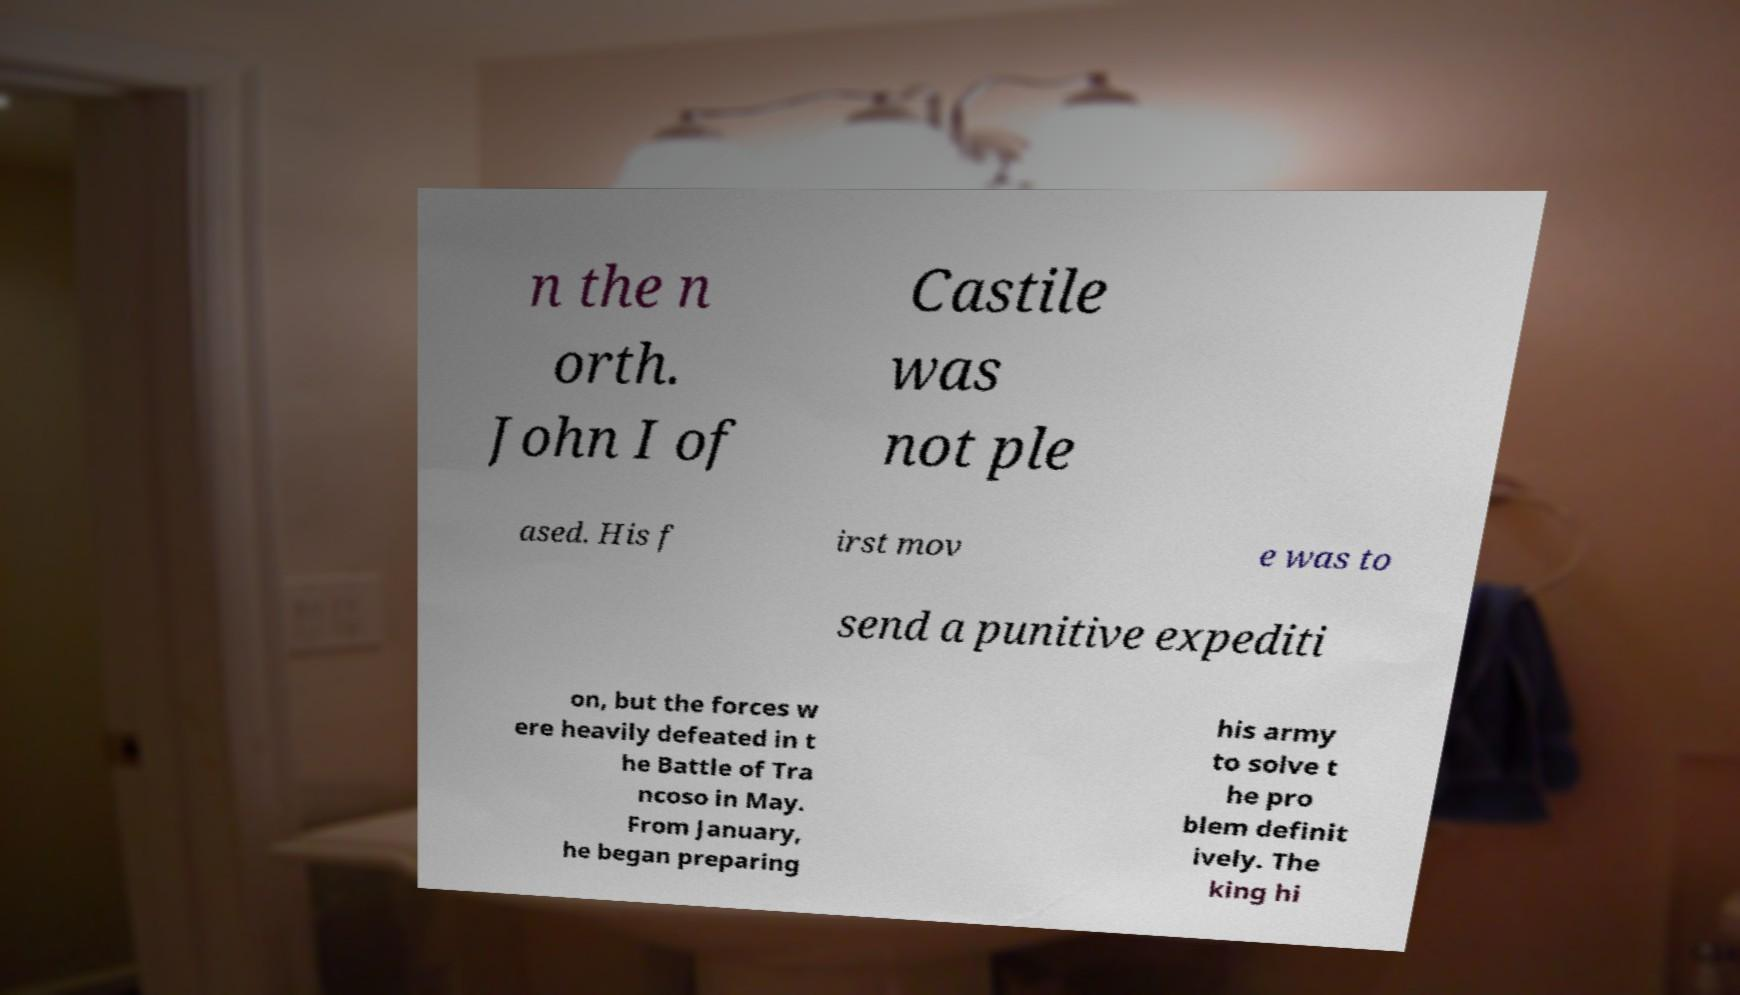Please identify and transcribe the text found in this image. n the n orth. John I of Castile was not ple ased. His f irst mov e was to send a punitive expediti on, but the forces w ere heavily defeated in t he Battle of Tra ncoso in May. From January, he began preparing his army to solve t he pro blem definit ively. The king hi 